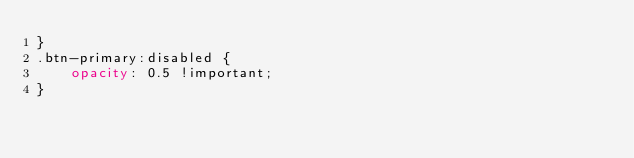<code> <loc_0><loc_0><loc_500><loc_500><_CSS_>}
.btn-primary:disabled {
    opacity: 0.5 !important;
}</code> 